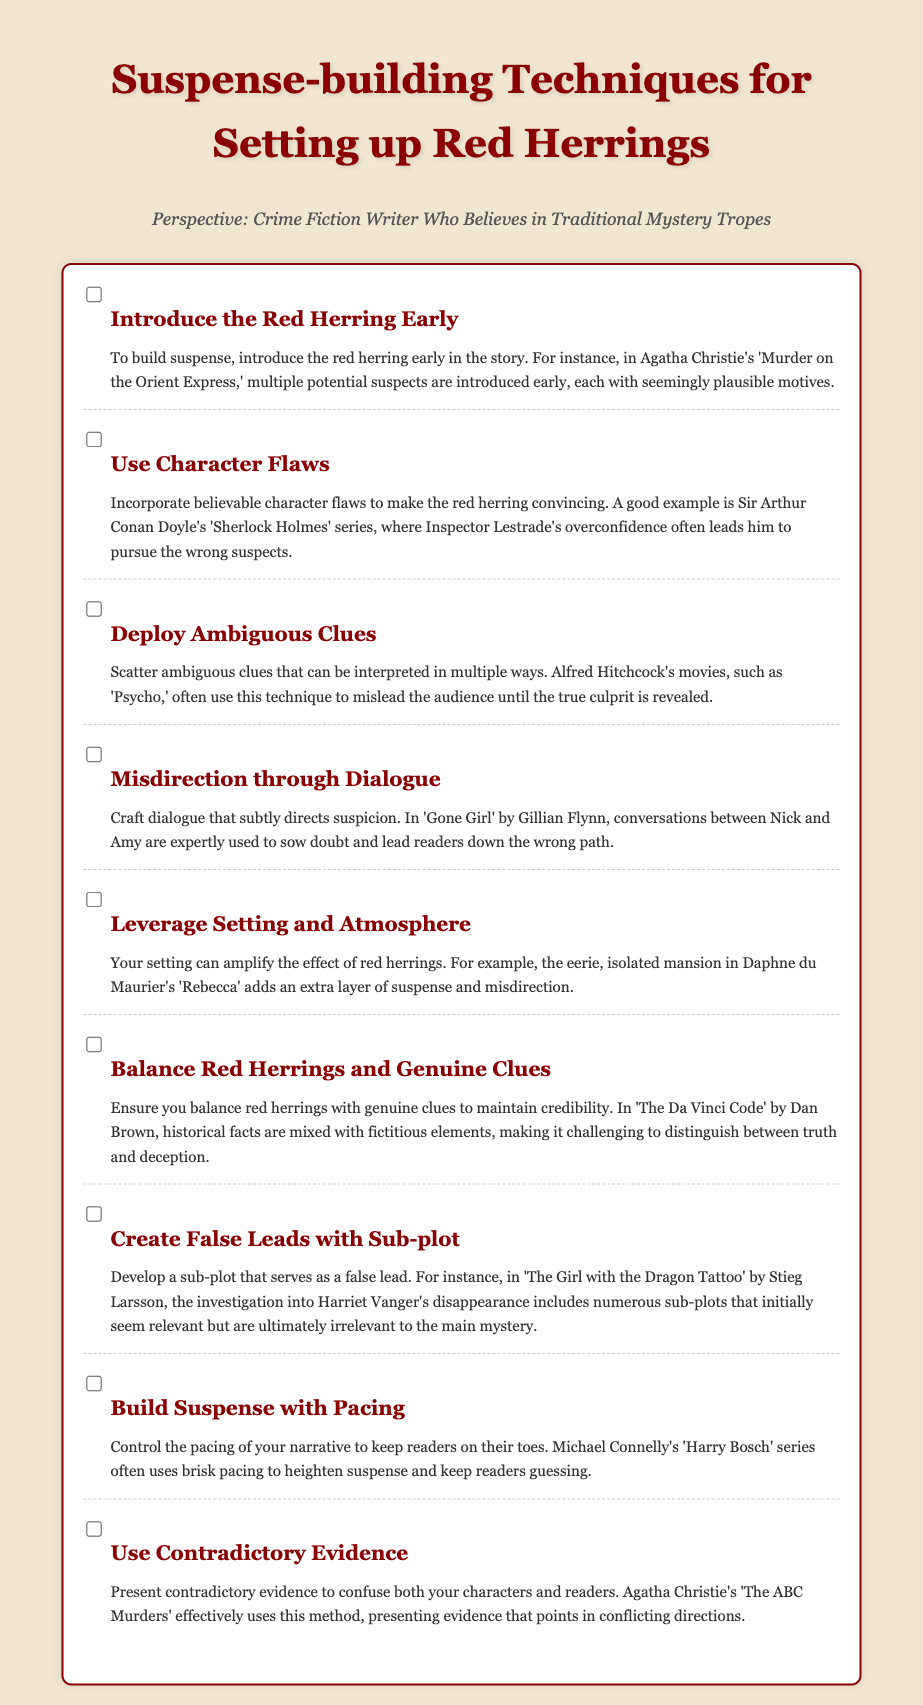What is the title of the document? The title is the main heading found at the top of the document.
Answer: Suspense-building Techniques for Setting up Red Herrings Who is the intended audience as stated in the document? The intended audience is mentioned in a specific line that conveys the perspective of the writer.
Answer: Crime Fiction Writer Who Believes in Traditional Mystery Tropes How many suspense-building techniques are listed in the checklist? The number of techniques is the total count of checklist items in the document.
Answer: Eight What is an example of a work mentioned that uses ambiguous clues? The document provides a specific film that showcases this technique.
Answer: Psycho Which author is cited for using character flaws as a technique? The author associated with the example highlighted in the section about character flaws is noted in the description.
Answer: Sir Arthur Conan Doyle What suspense-building technique involves balancing misleading and genuine clues? This specific technique aims to maintain the credibility of the narrative.
Answer: Balance Red Herrings and Genuine Clues In which example is a false lead through a subplot mentioned? The document specifies a novel that demonstrates the use of subplots to mislead.
Answer: The Girl with the Dragon Tattoo What pacing technique is noted to enhance suspense? This technique closely relates to how the story tempo affects reader engagement.
Answer: Build Suspense with Pacing 